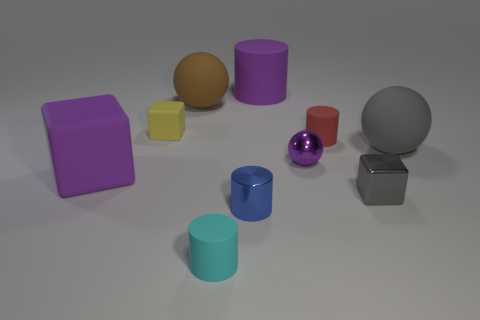Subtract 1 cylinders. How many cylinders are left? 3 Subtract all cylinders. How many objects are left? 6 Add 8 small blue shiny cylinders. How many small blue shiny cylinders are left? 9 Add 8 yellow matte cubes. How many yellow matte cubes exist? 9 Subtract 1 gray spheres. How many objects are left? 9 Subtract all tiny gray cylinders. Subtract all big blocks. How many objects are left? 9 